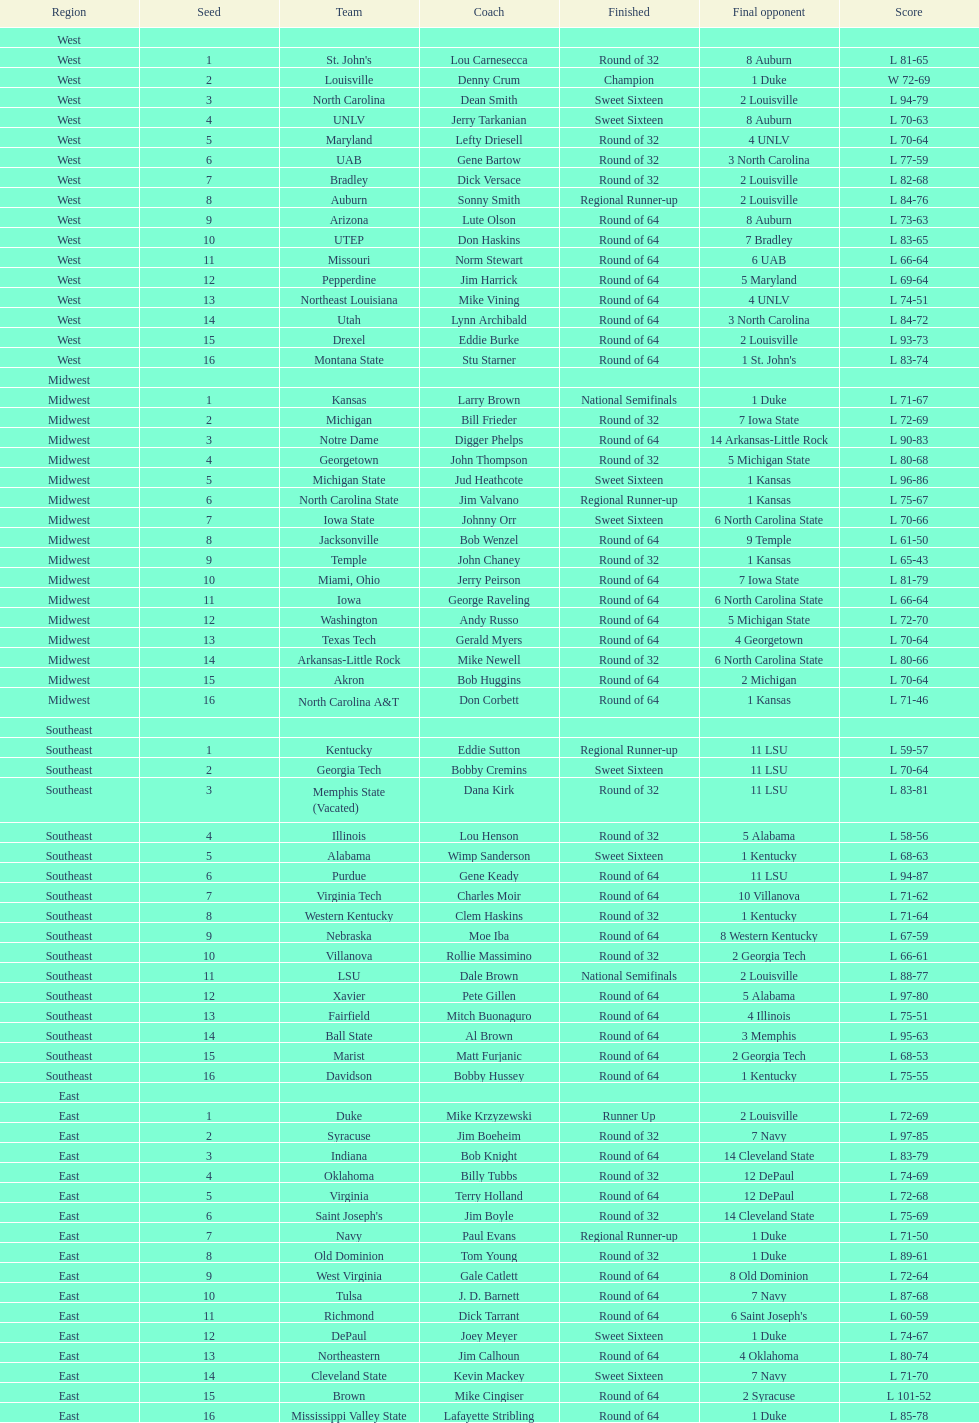Who was the unique winner? Louisville. 